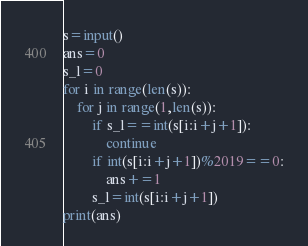Convert code to text. <code><loc_0><loc_0><loc_500><loc_500><_Python_>s=input()
ans=0
s_l=0
for i in range(len(s)):
    for j in range(1,len(s)):
        if s_l==int(s[i:i+j+1]):
            continue
        if int(s[i:i+j+1])%2019==0:
            ans+=1
        s_l=int(s[i:i+j+1])
print(ans)</code> 